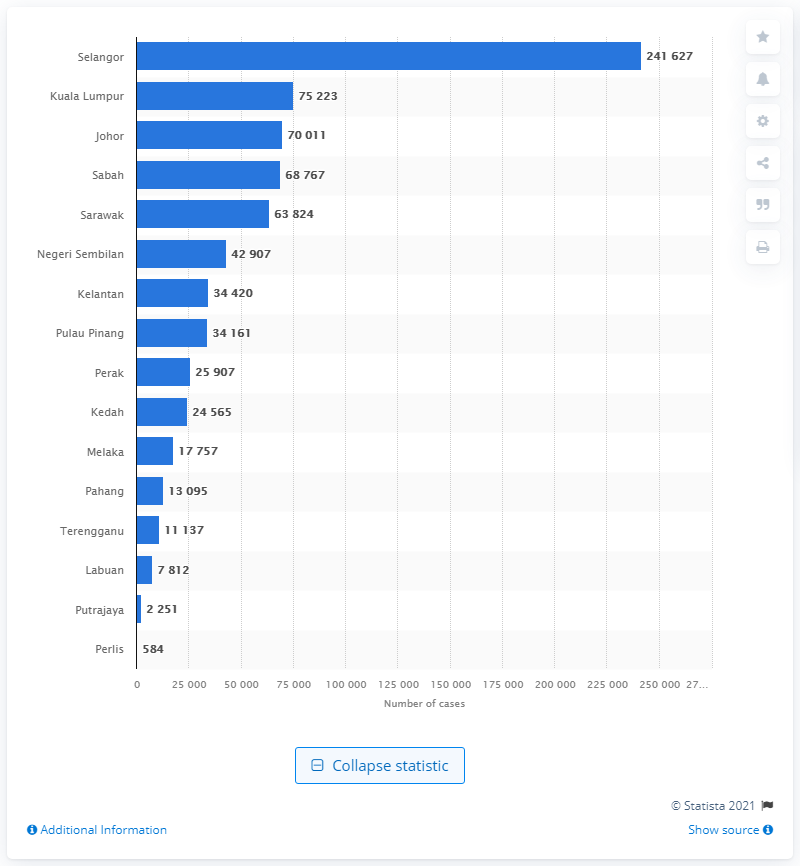Outline some significant characteristics in this image. As of June 27, 2021, there were a total of 241,627 confirmed cases of COVID-19 in Selangor. 